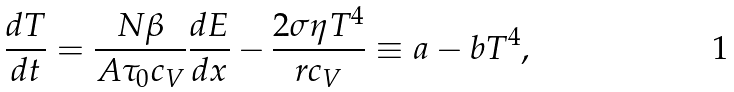Convert formula to latex. <formula><loc_0><loc_0><loc_500><loc_500>\frac { d T } { d t } = \frac { N \beta } { A \tau _ { 0 } c _ { V } } \frac { d E } { d x } - \frac { 2 \sigma \eta T ^ { 4 } } { r c _ { V } } \equiv a - b T ^ { 4 } ,</formula> 